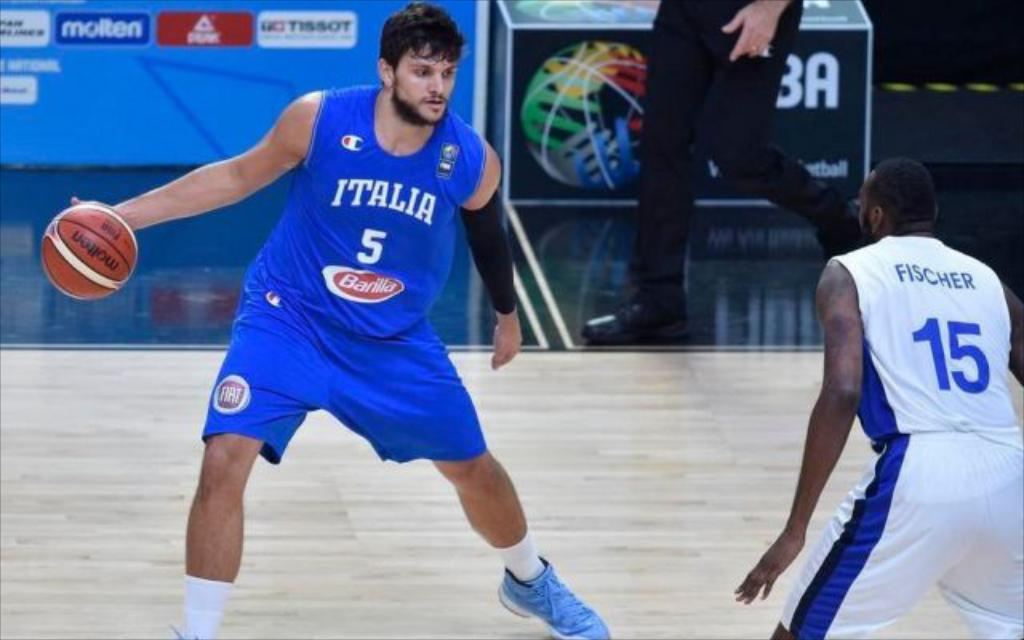<image>
Present a compact description of the photo's key features. A player in an Italia jersey has the basketball in his hand. 